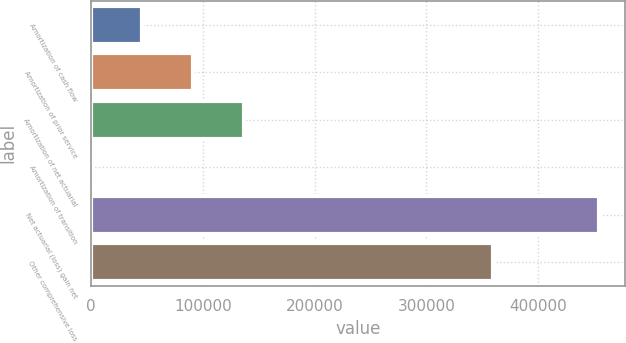Convert chart to OTSL. <chart><loc_0><loc_0><loc_500><loc_500><bar_chart><fcel>Amortization of cash flow<fcel>Amortization of prior service<fcel>Amortization of net actuarial<fcel>Amortization of transition<fcel>Net actuarial (loss) gain net<fcel>Other comprehensive loss<nl><fcel>45613.3<fcel>91073.6<fcel>136534<fcel>153<fcel>454756<fcel>359504<nl></chart> 